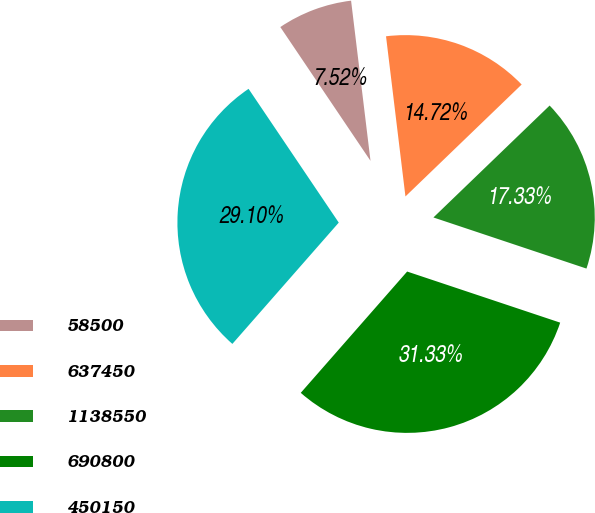Convert chart to OTSL. <chart><loc_0><loc_0><loc_500><loc_500><pie_chart><fcel>58500<fcel>637450<fcel>1138550<fcel>690800<fcel>450150<nl><fcel>7.52%<fcel>14.72%<fcel>17.33%<fcel>31.33%<fcel>29.1%<nl></chart> 